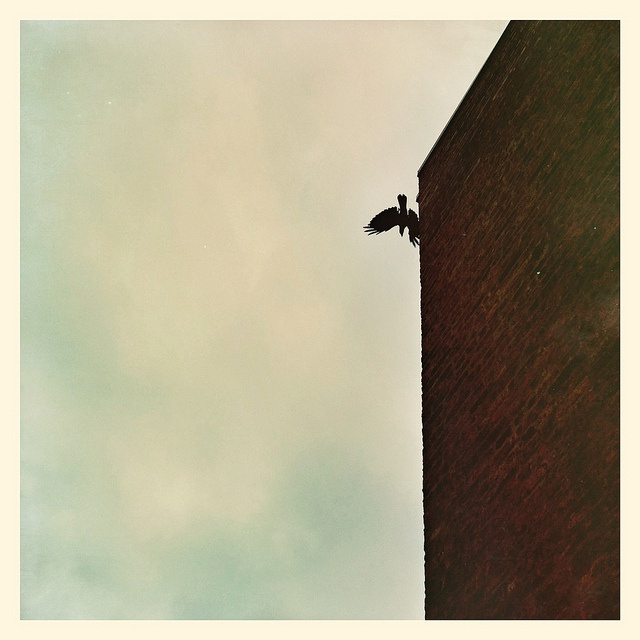Describe the objects in this image and their specific colors. I can see a bird in beige, black, lightgray, and gray tones in this image. 